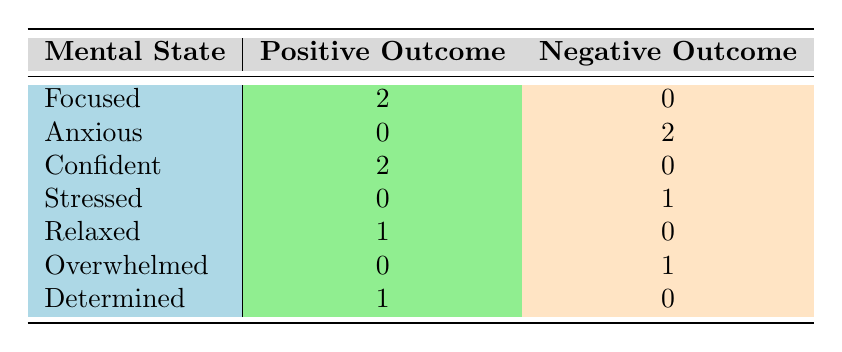What is the total number of positive outcomes? By counting the positive outcomes for each mental state in the table, we find (2 for Focused + 2 for Confident + 1 for Relaxed + 1 for Determined) = 6 positive outcomes total.
Answer: 6 How many athletes experienced an anxious mental state? The table shows that there are 2 athletes categorized under the anxious mental state, as seen in the entries for Simone Biles and Cristiano Ronaldo.
Answer: 2 Is it true that all athletes in the focused and confident categories achieved positive outcomes? Yes, examining the table reveals that all athletes categorized as focused (2) and confident (2) have positive outcomes (Gold Medal and Finals Win respectively).
Answer: Yes What is the difference in the number of negative outcomes between the anxious and stressed mental states? The table indicates that the anxious category has 2 negative outcomes, whereas the stressed category has 1. Thus, the difference is 2 - 1 = 1.
Answer: 1 What mental state had the highest positive outcome count? Upon reviewing the positive outcome counts per mental state, both focused and confident states have the highest count of 2, which is the maximum.
Answer: Focused and Confident How many athletes had a negative outcome and were in an overwhelmed mental state? From the table, it is clear that there is 1 athlete under the overwhelmed mental state who experienced a negative outcome (LeBron James).
Answer: 1 What percentage of athletes achieved a gold medal considering their mental state? There are 3 gold medals awarded (to Michael Phelps, Katie Ledecky, and Usain Bolt) out of a total of 10 athletes. Thus, the percentage is (3/10) * 100% = 30%.
Answer: 30% Which mental state had the least positive outcomes, and how many were there? The mental states of anxious and overwhelmed both show 0 positive outcomes, which is the lowest in the table.
Answer: Anxious and Overwhelmed, 0 